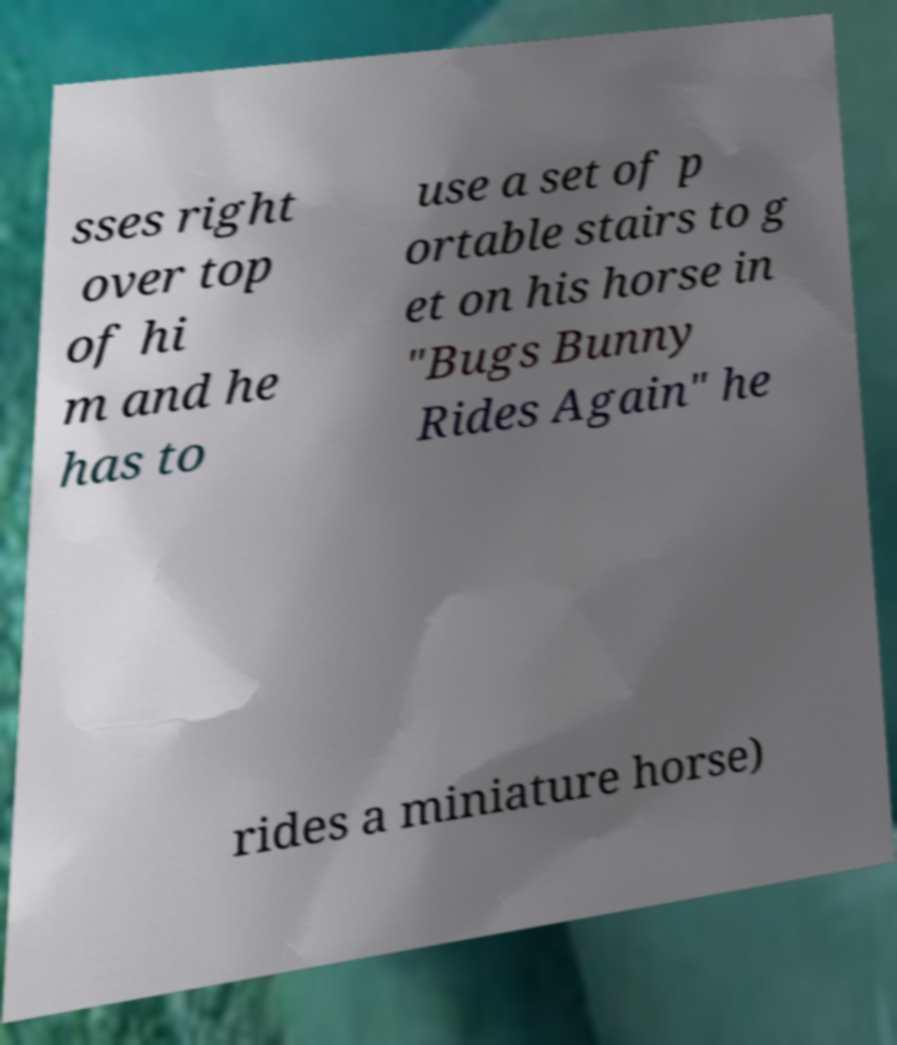Can you accurately transcribe the text from the provided image for me? sses right over top of hi m and he has to use a set of p ortable stairs to g et on his horse in "Bugs Bunny Rides Again" he rides a miniature horse) 